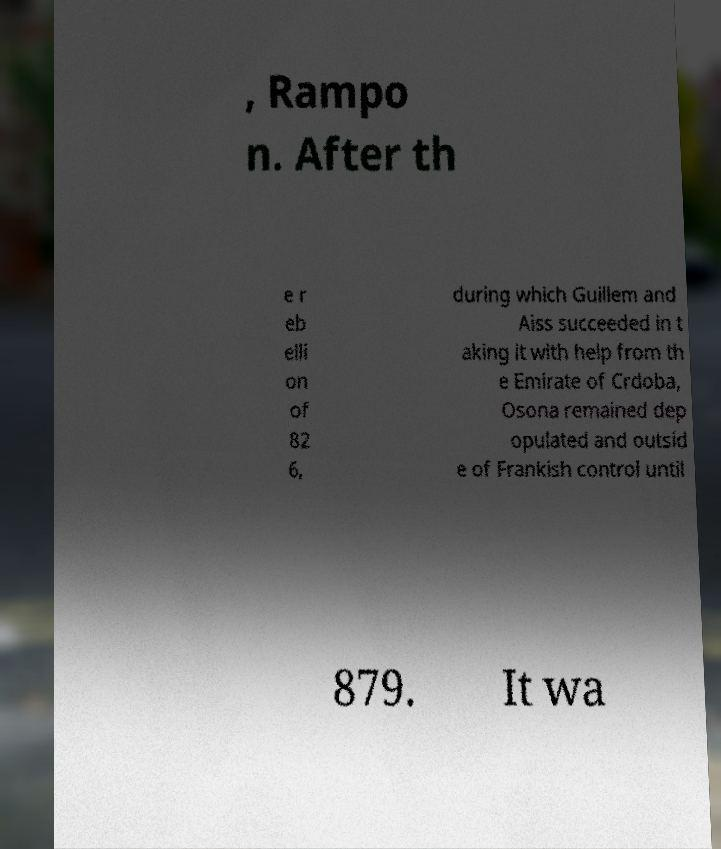Please identify and transcribe the text found in this image. , Rampo n. After th e r eb elli on of 82 6, during which Guillem and Aiss succeeded in t aking it with help from th e Emirate of Crdoba, Osona remained dep opulated and outsid e of Frankish control until 879. It wa 